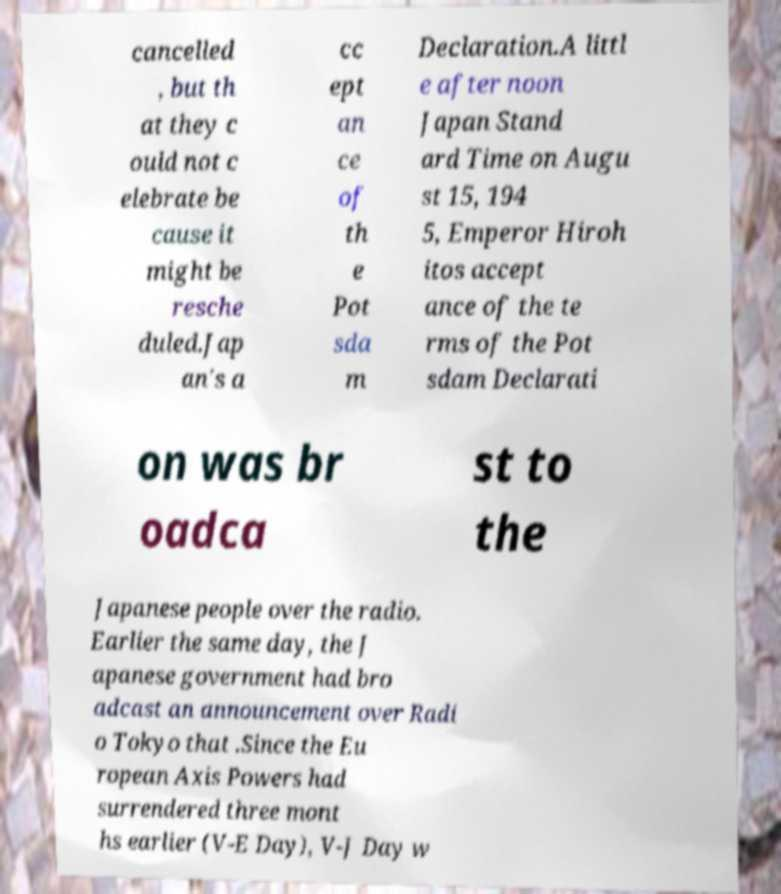I need the written content from this picture converted into text. Can you do that? cancelled , but th at they c ould not c elebrate be cause it might be resche duled.Jap an's a cc ept an ce of th e Pot sda m Declaration.A littl e after noon Japan Stand ard Time on Augu st 15, 194 5, Emperor Hiroh itos accept ance of the te rms of the Pot sdam Declarati on was br oadca st to the Japanese people over the radio. Earlier the same day, the J apanese government had bro adcast an announcement over Radi o Tokyo that .Since the Eu ropean Axis Powers had surrendered three mont hs earlier (V-E Day), V-J Day w 